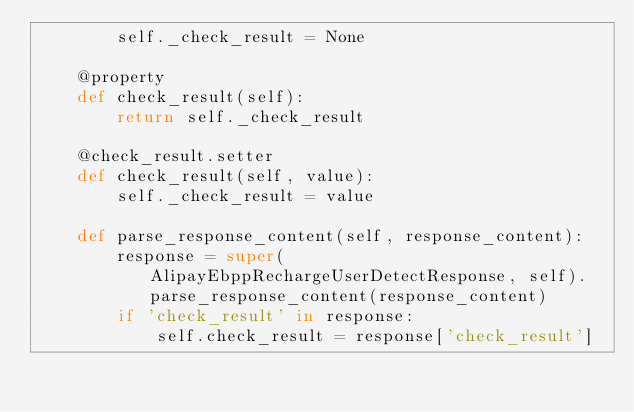Convert code to text. <code><loc_0><loc_0><loc_500><loc_500><_Python_>        self._check_result = None

    @property
    def check_result(self):
        return self._check_result

    @check_result.setter
    def check_result(self, value):
        self._check_result = value

    def parse_response_content(self, response_content):
        response = super(AlipayEbppRechargeUserDetectResponse, self).parse_response_content(response_content)
        if 'check_result' in response:
            self.check_result = response['check_result']
</code> 